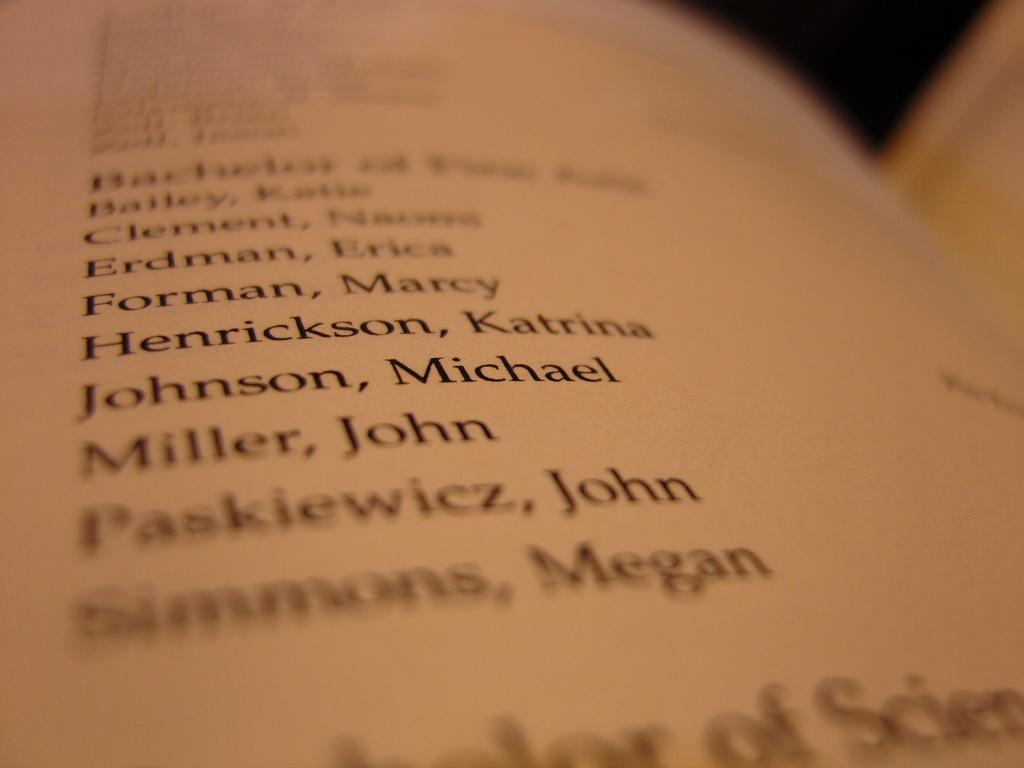<image>
Present a compact description of the photo's key features. A list of names is shown with the last entry being Simmons. 